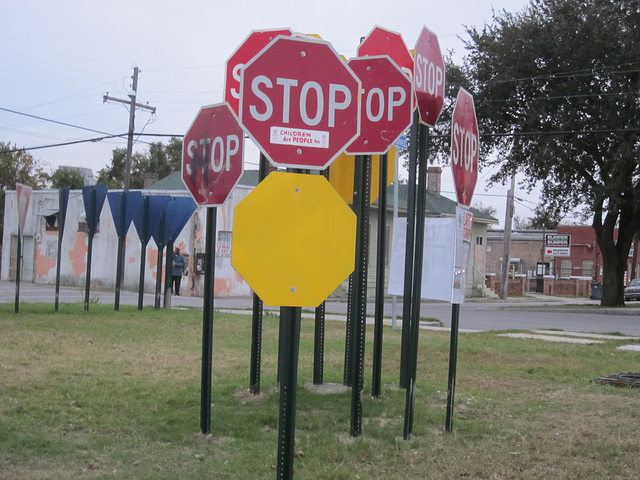Please extract the text content from this image. STOP OP STOP STOP STOP S 